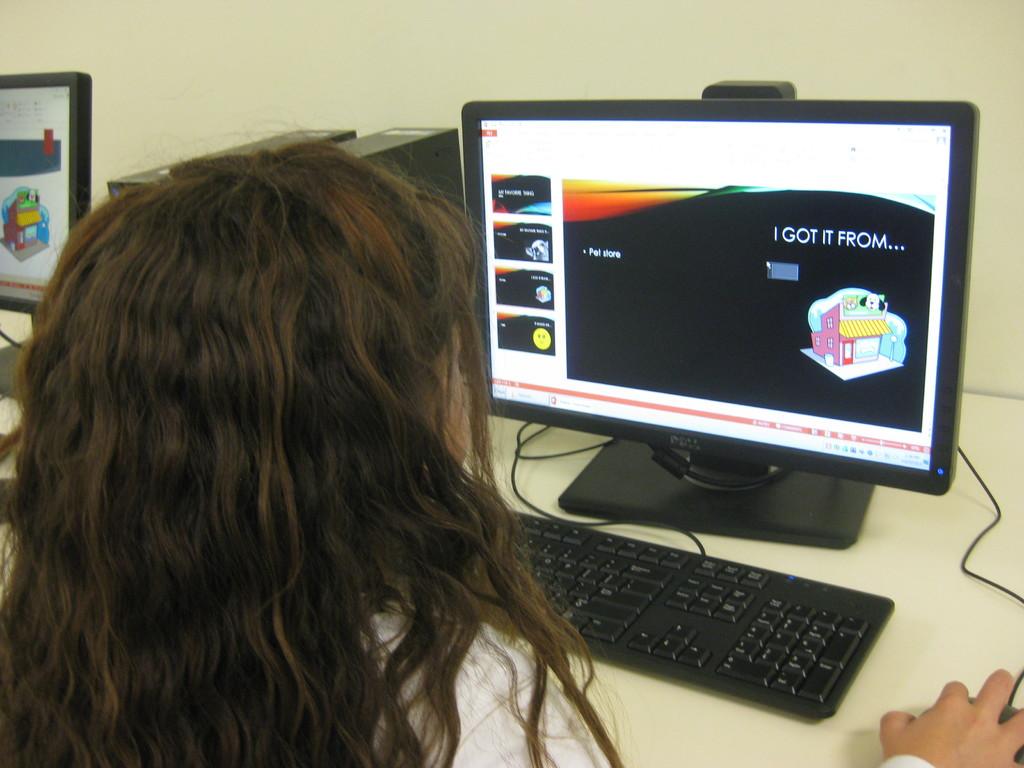What does it say on the slide on the screen?
Provide a short and direct response. I got it from. What brand is the computer monitor?
Provide a short and direct response. Dell. 